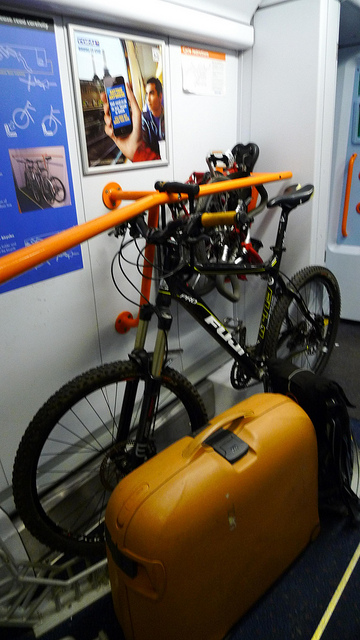Please identify all text content in this image. FUJI 